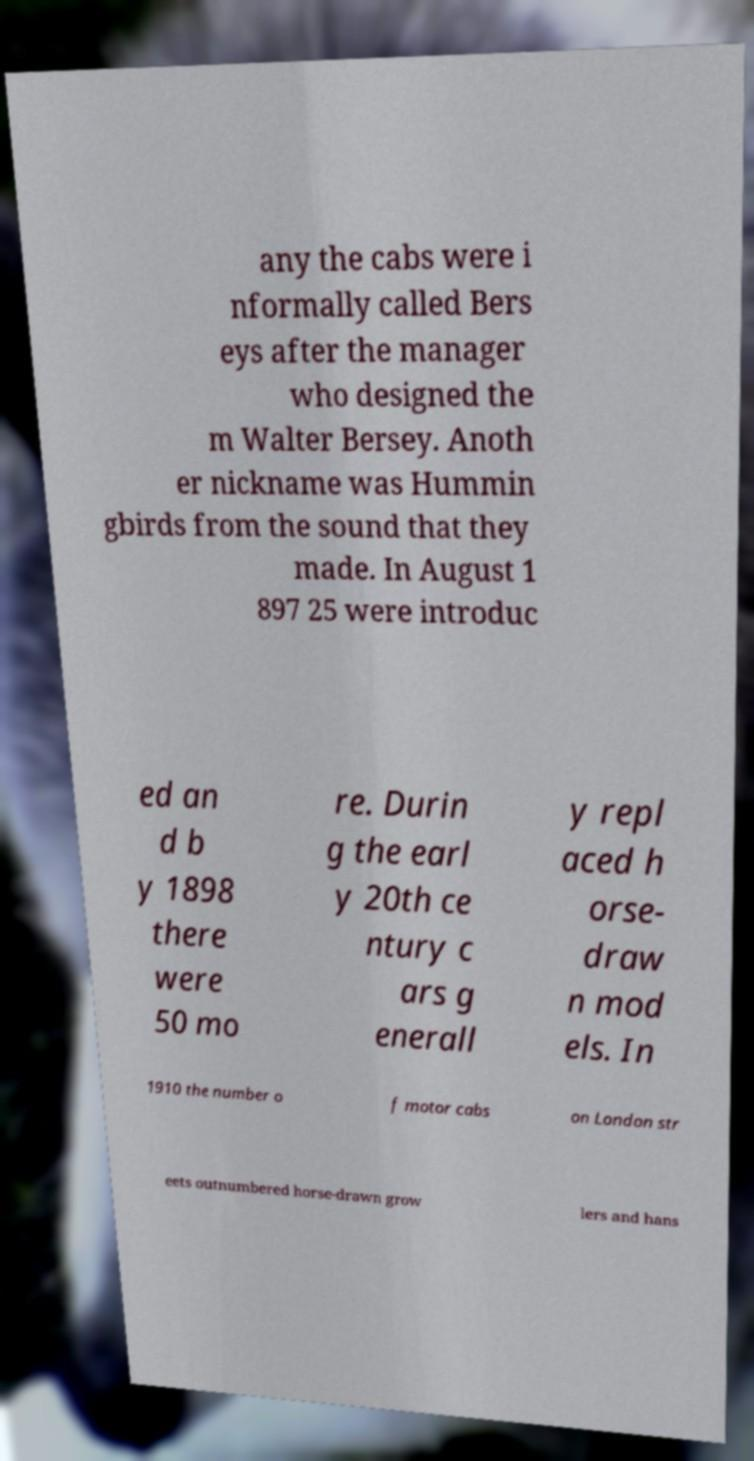Please identify and transcribe the text found in this image. any the cabs were i nformally called Bers eys after the manager who designed the m Walter Bersey. Anoth er nickname was Hummin gbirds from the sound that they made. In August 1 897 25 were introduc ed an d b y 1898 there were 50 mo re. Durin g the earl y 20th ce ntury c ars g enerall y repl aced h orse- draw n mod els. In 1910 the number o f motor cabs on London str eets outnumbered horse-drawn grow lers and hans 